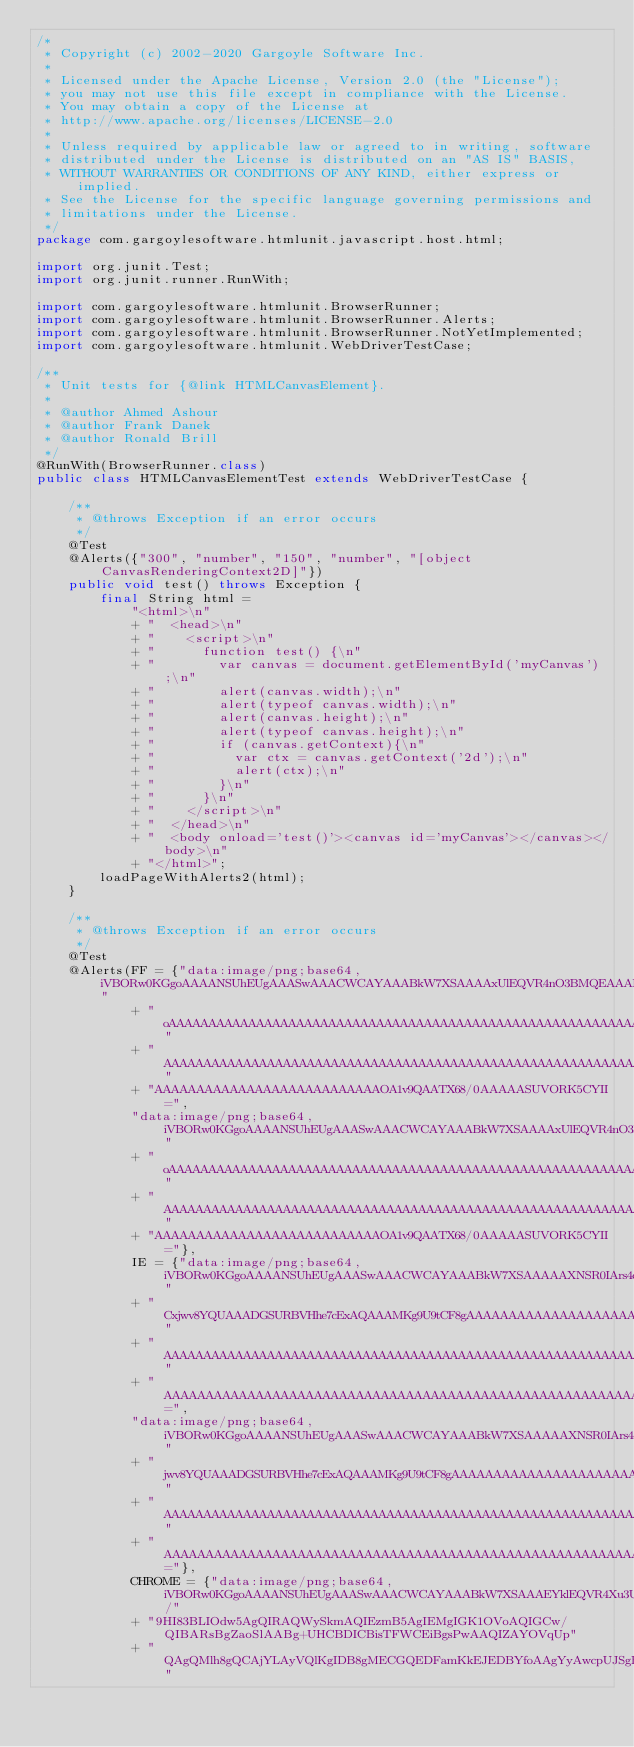<code> <loc_0><loc_0><loc_500><loc_500><_Java_>/*
 * Copyright (c) 2002-2020 Gargoyle Software Inc.
 *
 * Licensed under the Apache License, Version 2.0 (the "License");
 * you may not use this file except in compliance with the License.
 * You may obtain a copy of the License at
 * http://www.apache.org/licenses/LICENSE-2.0
 *
 * Unless required by applicable law or agreed to in writing, software
 * distributed under the License is distributed on an "AS IS" BASIS,
 * WITHOUT WARRANTIES OR CONDITIONS OF ANY KIND, either express or implied.
 * See the License for the specific language governing permissions and
 * limitations under the License.
 */
package com.gargoylesoftware.htmlunit.javascript.host.html;

import org.junit.Test;
import org.junit.runner.RunWith;

import com.gargoylesoftware.htmlunit.BrowserRunner;
import com.gargoylesoftware.htmlunit.BrowserRunner.Alerts;
import com.gargoylesoftware.htmlunit.BrowserRunner.NotYetImplemented;
import com.gargoylesoftware.htmlunit.WebDriverTestCase;

/**
 * Unit tests for {@link HTMLCanvasElement}.
 *
 * @author Ahmed Ashour
 * @author Frank Danek
 * @author Ronald Brill
 */
@RunWith(BrowserRunner.class)
public class HTMLCanvasElementTest extends WebDriverTestCase {

    /**
     * @throws Exception if an error occurs
     */
    @Test
    @Alerts({"300", "number", "150", "number", "[object CanvasRenderingContext2D]"})
    public void test() throws Exception {
        final String html =
            "<html>\n"
            + "  <head>\n"
            + "    <script>\n"
            + "      function test() {\n"
            + "        var canvas = document.getElementById('myCanvas');\n"
            + "        alert(canvas.width);\n"
            + "        alert(typeof canvas.width);\n"
            + "        alert(canvas.height);\n"
            + "        alert(typeof canvas.height);\n"
            + "        if (canvas.getContext){\n"
            + "          var ctx = canvas.getContext('2d');\n"
            + "          alert(ctx);\n"
            + "        }\n"
            + "      }\n"
            + "    </script>\n"
            + "  </head>\n"
            + "  <body onload='test()'><canvas id='myCanvas'></canvas></body>\n"
            + "</html>";
        loadPageWithAlerts2(html);
    }

    /**
     * @throws Exception if an error occurs
     */
    @Test
    @Alerts(FF = {"data:image/png;base64,iVBORw0KGgoAAAANSUhEUgAAASwAAACWCAYAAABkW7XSAAAAxUlEQVR4nO3BMQEAAADCoPVPbQhf"
            + "oAAAAAAAAAAAAAAAAAAAAAAAAAAAAAAAAAAAAAAAAAAAAAAAAAAAAAAAAAAAAAAAAAAAAAAAAAAAAAAAAAAAAAAAAAAAAAAAAAAAAAA"
            + "AAAAAAAAAAAAAAAAAAAAAAAAAAAAAAAAAAAAAAAAAAAAAAAAAAAAAAAAAAAAAAAAAAAAAAAAAAAAAAAAAAAAAAAAAAAAAAAAAAAAAAA"
            + "AAAAAAAAAAAAAAAAAAAAAAAAAAAOA1v9QAATX68/0AAAAASUVORK5CYII=",
            "data:image/png;base64,iVBORw0KGgoAAAANSUhEUgAAASwAAACWCAYAAABkW7XSAAAAxUlEQVR4nO3BMQEAAADCoPVPbQhf"
            + "oAAAAAAAAAAAAAAAAAAAAAAAAAAAAAAAAAAAAAAAAAAAAAAAAAAAAAAAAAAAAAAAAAAAAAAAAAAAAAAAAAAAAAAAAAAAAAAAAAAAAAA"
            + "AAAAAAAAAAAAAAAAAAAAAAAAAAAAAAAAAAAAAAAAAAAAAAAAAAAAAAAAAAAAAAAAAAAAAAAAAAAAAAAAAAAAAAAAAAAAAAAAAAAAAAA"
            + "AAAAAAAAAAAAAAAAAAAAAAAAAAAOA1v9QAATX68/0AAAAASUVORK5CYII="},
            IE = {"data:image/png;base64,iVBORw0KGgoAAAANSUhEUgAAASwAAACWCAYAAABkW7XSAAAAAXNSR0IArs4c6QAAAARnQU1BAA"
            + "Cxjwv8YQUAAADGSURBVHhe7cExAQAAAMKg9U9tCF8gAAAAAAAAAAAAAAAAAAAAAAAAAAAAAAAAAAAAAAAAAAAAAAAAAAAAAAAAAAAAA"
            + "AAAAAAAAAAAAAAAAAAAAAAAAAAAAAAAAAAAAAAAAAAAAAAAAAAAAAAAAAAAAAAAAAAAAAAAAAAAAAAAAAAAAAAAAAAAAAAAAAAAAAAA"
            + "AAAAAAAAAAAAAAAAAAAAAAAAAAAAAAAAAAAAAAAAAAAAAAAAAAAAAAAAAAAAAAAAAAAAONUAv9QAAcDhjokAAAAASUVORK5CYII=",
            "data:image/png;base64,iVBORw0KGgoAAAANSUhEUgAAASwAAACWCAYAAABkW7XSAAAAAXNSR0IArs4c6QAAAARnQU1BAACx"
            + "jwv8YQUAAADGSURBVHhe7cExAQAAAMKg9U9tCF8gAAAAAAAAAAAAAAAAAAAAAAAAAAAAAAAAAAAAAAAAAAAAAAAAAAAAAAAAAAAAAAA"
            + "AAAAAAAAAAAAAAAAAAAAAAAAAAAAAAAAAAAAAAAAAAAAAAAAAAAAAAAAAAAAAAAAAAAAAAAAAAAAAAAAAAAAAAAAAAAAAAAAAAAAAAA"
            + "AAAAAAAAAAAAAAAAAAAAAAAAAAAAAAAAAAAAAAAAAAAAAAAAAAAAAAAAAAAAAAAAAAONUAv9QAAcDhjokAAAAASUVORK5CYII="},
            CHROME = {"data:image/png;base64,iVBORw0KGgoAAAANSUhEUgAAASwAAACWCAYAAABkW7XSAAAEYklEQVR4Xu3UAQkAAAwCwdm/"
            + "9HI83BLIOdw5AgQIRAQWySkmAQIEzmB5AgIEMgIGK1OVoAQIGCw/QIBARsBgZaoSlAABg+UHCBDICBisTFWCEiBgsPwAAQIZAYOVqUp"
            + "QAgQMlh8gQCAjYLAyVQlKgIDB8gMECGQEDFamKkEJEDBYfoAAgYyAwcpUJSgBAgbLDxAgkBEwWJmqBCVAwGD5AQIEMgIGK1OVoAQIGC"</code> 